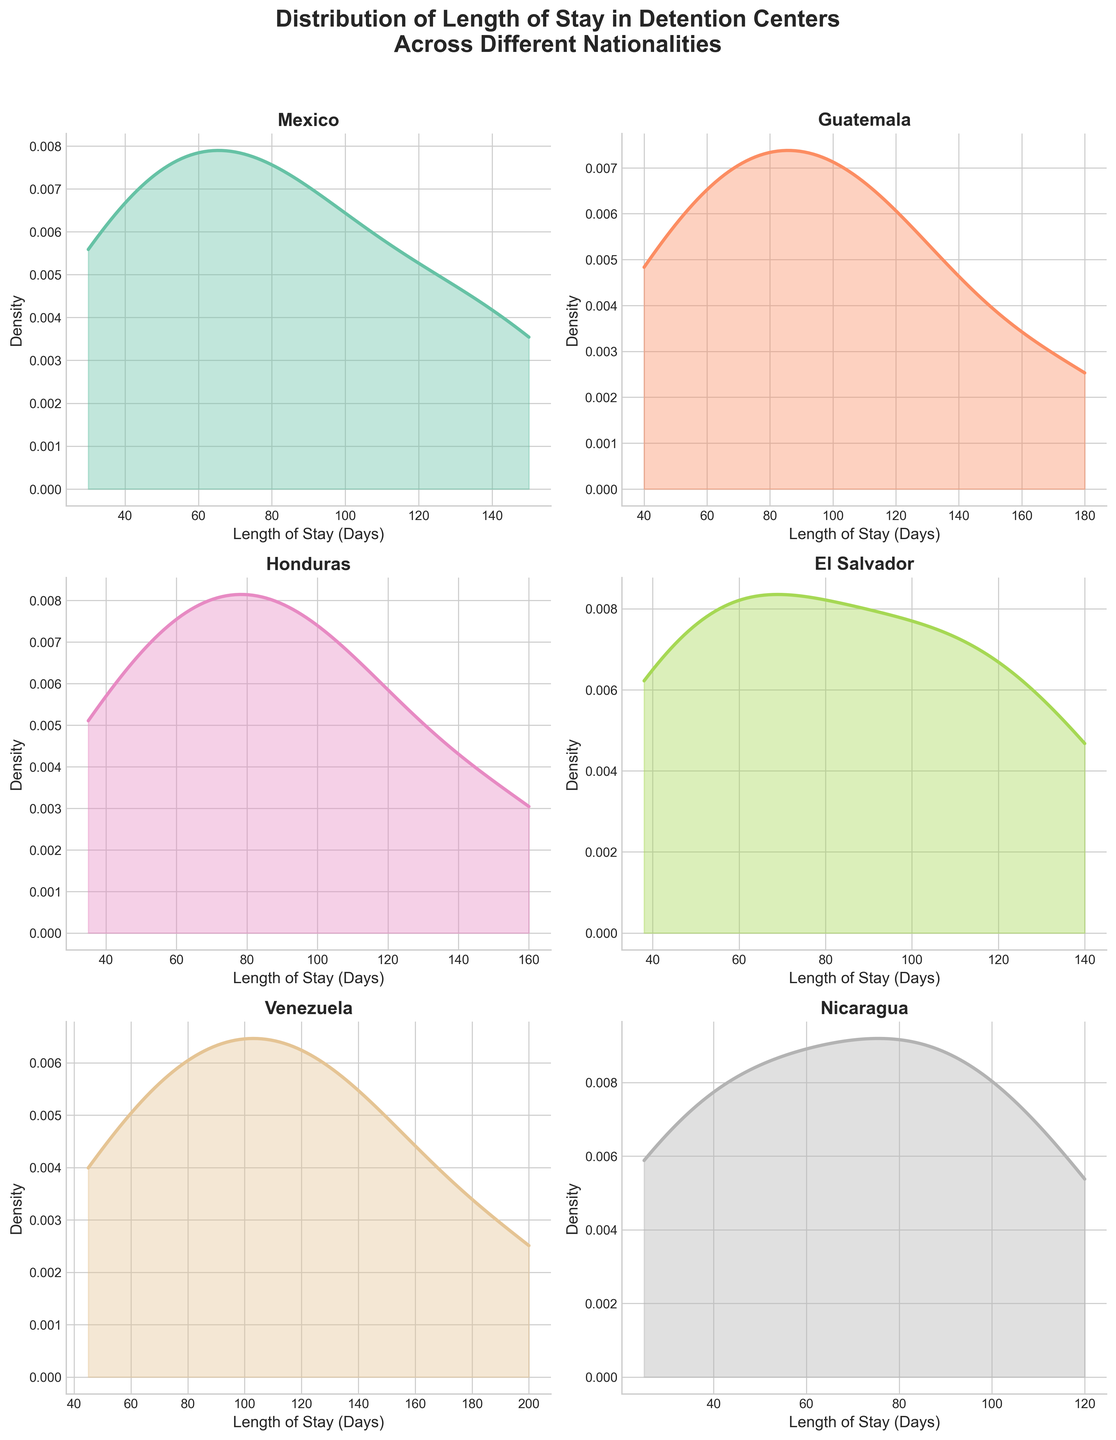What is the overall title of the figure? The overall title of the figure is often placed at the top of the plot and summarizes the visualized data. In this case, it explicitly states, "Distribution of Length of Stay in Detention Centers Across Different Nationalities."
Answer: Distribution of Length of Stay in Detention Centers Across Different Nationalities Which nationality has a peak density at the lowest length of stay? To identify the nationality with a peak density at the lowest length of stay, we need to look at the curves' peaks and find the one closest to the vertical axis.
Answer: Nicaragua Which nationality has the widest range of length of stay? Determining the widest range involves looking at the x-axis extents for each subplot. The nationality with the longest span from minimum to maximum represents the widest range.
Answer: Venezuela For Mexico, around how many days is the peak density located? The peak density in a density plot is identified by the highest point of the curve. For Mexico, find the x-axis value (days) at this peak.
Answer: Around 90 days Between Guatemala and Honduras, which nationality has a higher density value at 100 days? At the 100-day mark on the x-axis for both nationalities, compare the density values (y-axis). The nationality with the higher point indicates a greater density.
Answer: Guatemala How do the shapes of the distributions for El Salvador and Nicaragua compare? Comparing shapes involves looking at the spread, skewness, peaks, and overall form of the density curves. El Salvador's curve is more centrally peaked, while Nicaragua's is more spread out.
Answer: El Salvador is more centrally peaked; Nicaragua is more spread out Which nationality shows the most variability in the length of stay? Variability can be inferred from the spread of the density plot. A wider and flatter curve suggests higher variability, while narrow and tall curves suggest lower variability.
Answer: Venezuela Do any nationalities have more than one peak in their distribution (bimodal distribution)? Bimodal distributions display two prominent peaks in the density plot. Observing each plot can reveal if any nationality has such characteristics.
Answer: No What is the main difference between the density plot of Mexico and that of Venezuela? The main difference is observed in the range and peak of the density plots. Mexico has a narrower range and a lower peak, while Venezuela has a wider range and may have multiple significant features.
Answer: Mexico is narrower; Venezuela is wider and may have multiple significant features Which nationality’s peak density is closest to 50 days? Looking at the density plots, identify which subplot has its highest point nearest to the 50-day mark on the x-axis.
Answer: El Salvador 